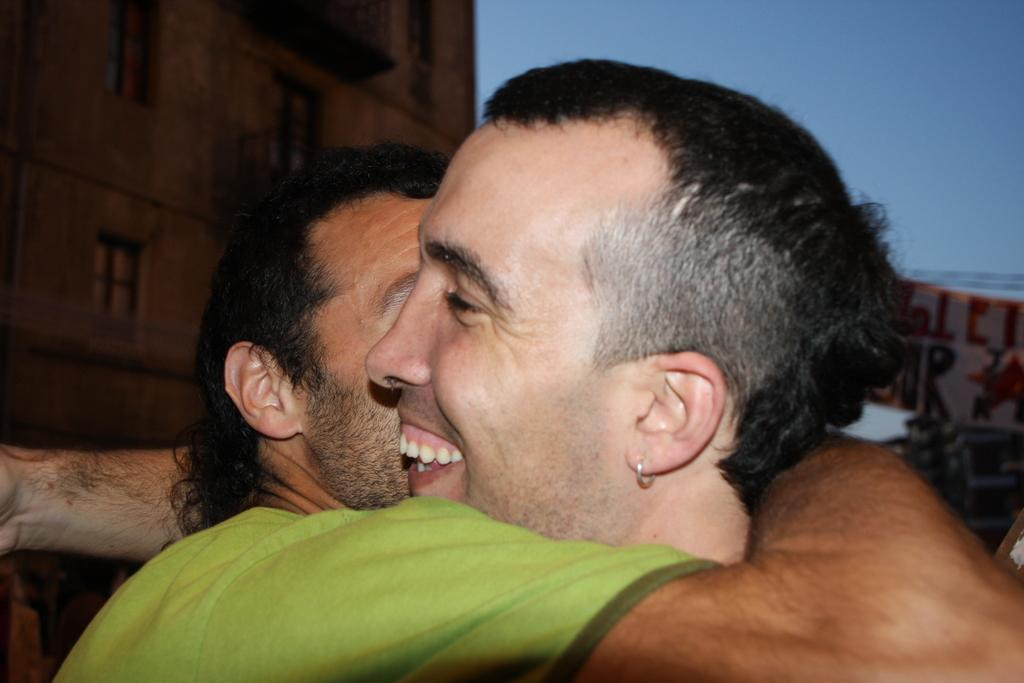How many people are in the foreground of the image? There are two men in the foreground of the image. What are the two men doing in the image? The two men are hugging each other. What can be seen in the background of the image? There is a building and the sky visible in the background of the image. What type of pie is being shared between the two men in the image? There is no pie present in the image; the two men are hugging each other. How are the two men playing together in the image? The two men are not playing in the image; they are hugging each other. 